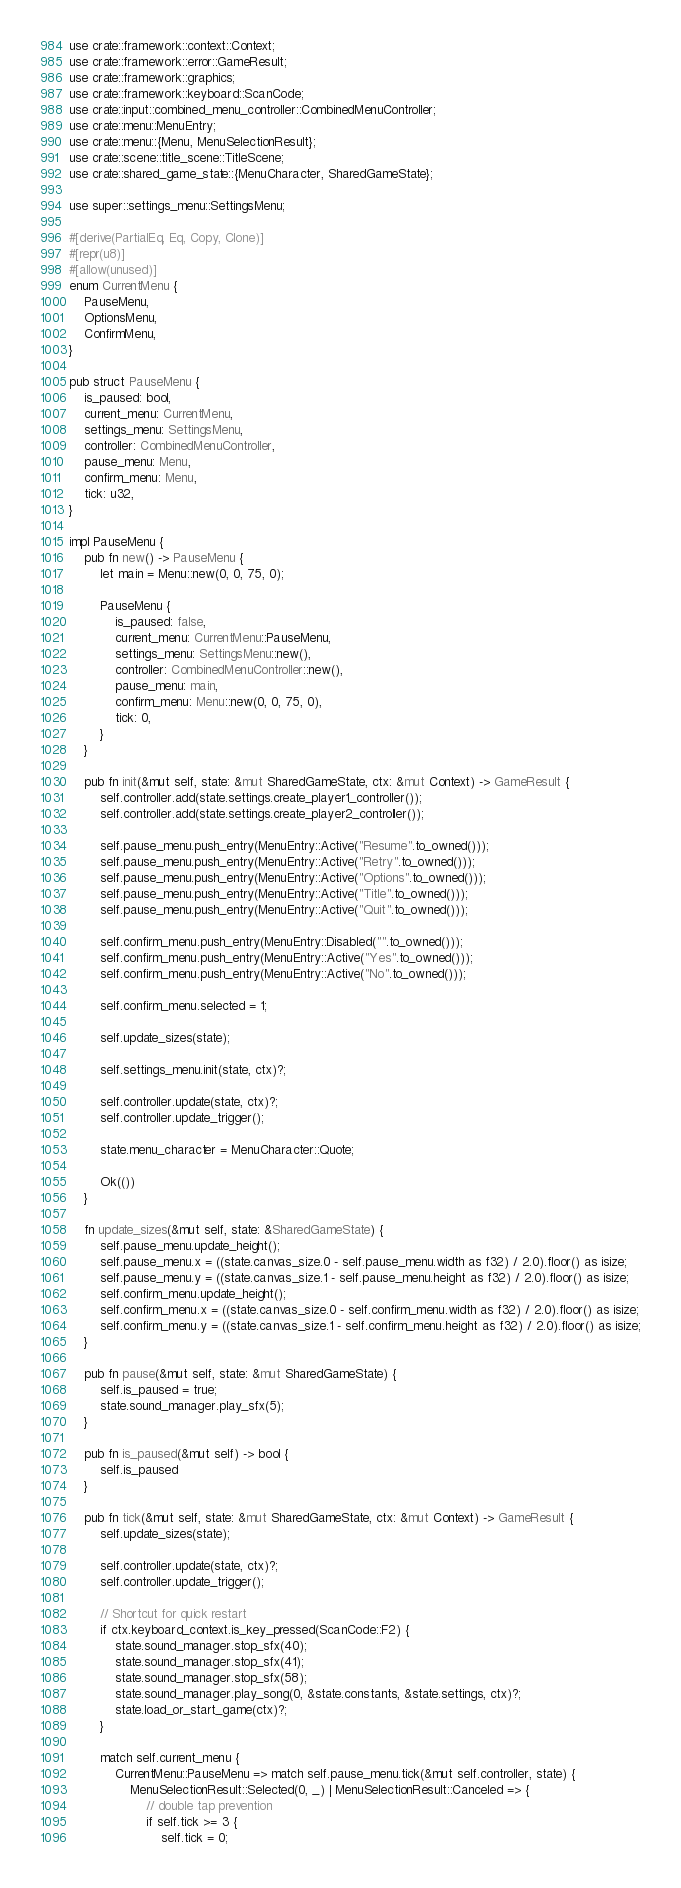<code> <loc_0><loc_0><loc_500><loc_500><_Rust_>use crate::framework::context::Context;
use crate::framework::error::GameResult;
use crate::framework::graphics;
use crate::framework::keyboard::ScanCode;
use crate::input::combined_menu_controller::CombinedMenuController;
use crate::menu::MenuEntry;
use crate::menu::{Menu, MenuSelectionResult};
use crate::scene::title_scene::TitleScene;
use crate::shared_game_state::{MenuCharacter, SharedGameState};

use super::settings_menu::SettingsMenu;

#[derive(PartialEq, Eq, Copy, Clone)]
#[repr(u8)]
#[allow(unused)]
enum CurrentMenu {
    PauseMenu,
    OptionsMenu,
    ConfirmMenu,
}

pub struct PauseMenu {
    is_paused: bool,
    current_menu: CurrentMenu,
    settings_menu: SettingsMenu,
    controller: CombinedMenuController,
    pause_menu: Menu,
    confirm_menu: Menu,
    tick: u32,
}

impl PauseMenu {
    pub fn new() -> PauseMenu {
        let main = Menu::new(0, 0, 75, 0);

        PauseMenu {
            is_paused: false,
            current_menu: CurrentMenu::PauseMenu,
            settings_menu: SettingsMenu::new(),
            controller: CombinedMenuController::new(),
            pause_menu: main,
            confirm_menu: Menu::new(0, 0, 75, 0),
            tick: 0,
        }
    }

    pub fn init(&mut self, state: &mut SharedGameState, ctx: &mut Context) -> GameResult {
        self.controller.add(state.settings.create_player1_controller());
        self.controller.add(state.settings.create_player2_controller());

        self.pause_menu.push_entry(MenuEntry::Active("Resume".to_owned()));
        self.pause_menu.push_entry(MenuEntry::Active("Retry".to_owned()));
        self.pause_menu.push_entry(MenuEntry::Active("Options".to_owned()));
        self.pause_menu.push_entry(MenuEntry::Active("Title".to_owned()));
        self.pause_menu.push_entry(MenuEntry::Active("Quit".to_owned()));

        self.confirm_menu.push_entry(MenuEntry::Disabled("".to_owned()));
        self.confirm_menu.push_entry(MenuEntry::Active("Yes".to_owned()));
        self.confirm_menu.push_entry(MenuEntry::Active("No".to_owned()));

        self.confirm_menu.selected = 1;

        self.update_sizes(state);

        self.settings_menu.init(state, ctx)?;

        self.controller.update(state, ctx)?;
        self.controller.update_trigger();

        state.menu_character = MenuCharacter::Quote;

        Ok(())
    }

    fn update_sizes(&mut self, state: &SharedGameState) {
        self.pause_menu.update_height();
        self.pause_menu.x = ((state.canvas_size.0 - self.pause_menu.width as f32) / 2.0).floor() as isize;
        self.pause_menu.y = ((state.canvas_size.1 - self.pause_menu.height as f32) / 2.0).floor() as isize;
        self.confirm_menu.update_height();
        self.confirm_menu.x = ((state.canvas_size.0 - self.confirm_menu.width as f32) / 2.0).floor() as isize;
        self.confirm_menu.y = ((state.canvas_size.1 - self.confirm_menu.height as f32) / 2.0).floor() as isize;
    }

    pub fn pause(&mut self, state: &mut SharedGameState) {
        self.is_paused = true;
        state.sound_manager.play_sfx(5);
    }

    pub fn is_paused(&mut self) -> bool {
        self.is_paused
    }

    pub fn tick(&mut self, state: &mut SharedGameState, ctx: &mut Context) -> GameResult {
        self.update_sizes(state);

        self.controller.update(state, ctx)?;
        self.controller.update_trigger();

        // Shortcut for quick restart
        if ctx.keyboard_context.is_key_pressed(ScanCode::F2) {
            state.sound_manager.stop_sfx(40);
            state.sound_manager.stop_sfx(41);
            state.sound_manager.stop_sfx(58);
            state.sound_manager.play_song(0, &state.constants, &state.settings, ctx)?;
            state.load_or_start_game(ctx)?;
        }

        match self.current_menu {
            CurrentMenu::PauseMenu => match self.pause_menu.tick(&mut self.controller, state) {
                MenuSelectionResult::Selected(0, _) | MenuSelectionResult::Canceled => {
                    // double tap prevention
                    if self.tick >= 3 {
                        self.tick = 0;</code> 